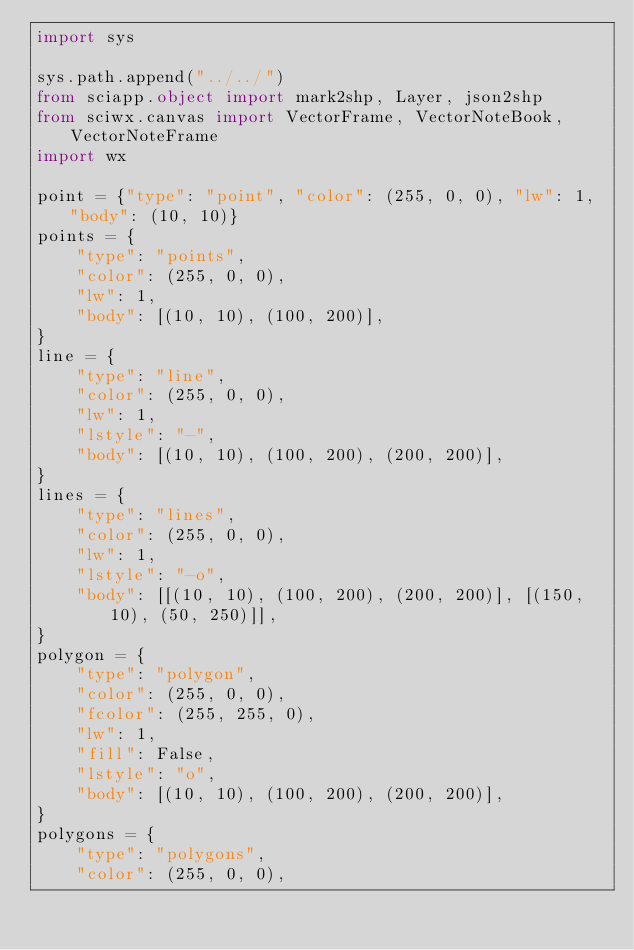Convert code to text. <code><loc_0><loc_0><loc_500><loc_500><_Python_>import sys

sys.path.append("../../")
from sciapp.object import mark2shp, Layer, json2shp
from sciwx.canvas import VectorFrame, VectorNoteBook, VectorNoteFrame
import wx

point = {"type": "point", "color": (255, 0, 0), "lw": 1, "body": (10, 10)}
points = {
    "type": "points",
    "color": (255, 0, 0),
    "lw": 1,
    "body": [(10, 10), (100, 200)],
}
line = {
    "type": "line",
    "color": (255, 0, 0),
    "lw": 1,
    "lstyle": "-",
    "body": [(10, 10), (100, 200), (200, 200)],
}
lines = {
    "type": "lines",
    "color": (255, 0, 0),
    "lw": 1,
    "lstyle": "-o",
    "body": [[(10, 10), (100, 200), (200, 200)], [(150, 10), (50, 250)]],
}
polygon = {
    "type": "polygon",
    "color": (255, 0, 0),
    "fcolor": (255, 255, 0),
    "lw": 1,
    "fill": False,
    "lstyle": "o",
    "body": [(10, 10), (100, 200), (200, 200)],
}
polygons = {
    "type": "polygons",
    "color": (255, 0, 0),</code> 